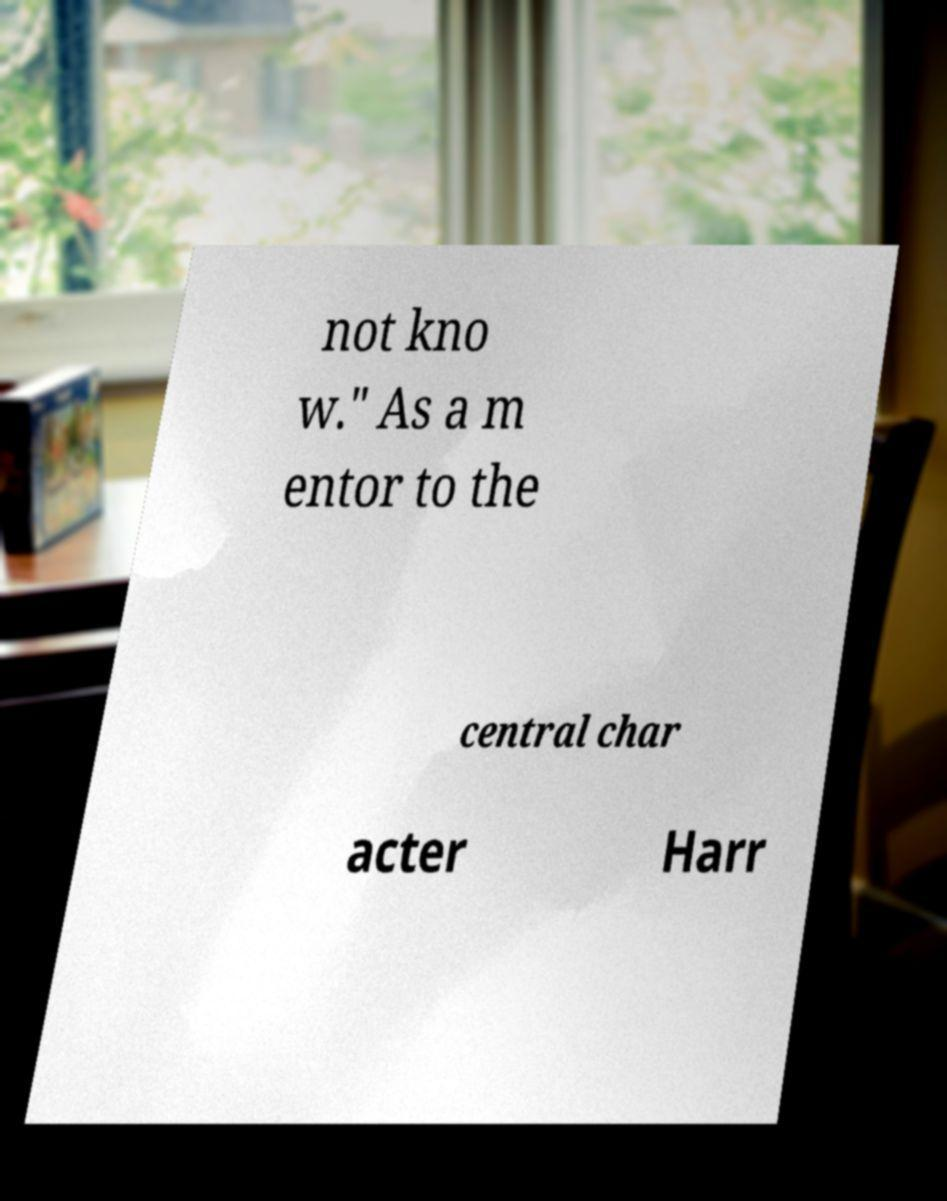There's text embedded in this image that I need extracted. Can you transcribe it verbatim? not kno w." As a m entor to the central char acter Harr 